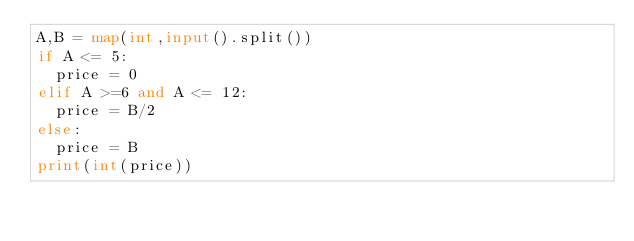Convert code to text. <code><loc_0><loc_0><loc_500><loc_500><_Python_>A,B = map(int,input().split())
if A <= 5:
  price = 0
elif A >=6 and A <= 12:
  price = B/2
else:
  price = B
print(int(price))
</code> 